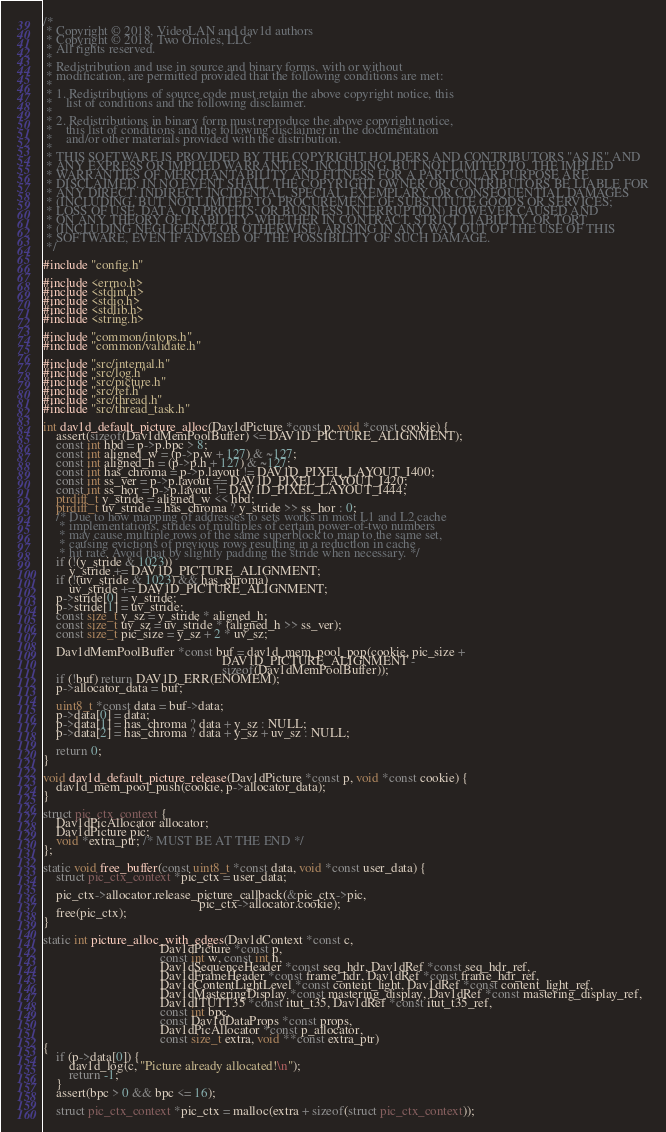Convert code to text. <code><loc_0><loc_0><loc_500><loc_500><_C_>/*
 * Copyright © 2018, VideoLAN and dav1d authors
 * Copyright © 2018, Two Orioles, LLC
 * All rights reserved.
 *
 * Redistribution and use in source and binary forms, with or without
 * modification, are permitted provided that the following conditions are met:
 *
 * 1. Redistributions of source code must retain the above copyright notice, this
 *    list of conditions and the following disclaimer.
 *
 * 2. Redistributions in binary form must reproduce the above copyright notice,
 *    this list of conditions and the following disclaimer in the documentation
 *    and/or other materials provided with the distribution.
 *
 * THIS SOFTWARE IS PROVIDED BY THE COPYRIGHT HOLDERS AND CONTRIBUTORS "AS IS" AND
 * ANY EXPRESS OR IMPLIED WARRANTIES, INCLUDING, BUT NOT LIMITED TO, THE IMPLIED
 * WARRANTIES OF MERCHANTABILITY AND FITNESS FOR A PARTICULAR PURPOSE ARE
 * DISCLAIMED. IN NO EVENT SHALL THE COPYRIGHT OWNER OR CONTRIBUTORS BE LIABLE FOR
 * ANY DIRECT, INDIRECT, INCIDENTAL, SPECIAL, EXEMPLARY, OR CONSEQUENTIAL DAMAGES
 * (INCLUDING, BUT NOT LIMITED TO, PROCUREMENT OF SUBSTITUTE GOODS OR SERVICES;
 * LOSS OF USE, DATA, OR PROFITS; OR BUSINESS INTERRUPTION) HOWEVER CAUSED AND
 * ON ANY THEORY OF LIABILITY, WHETHER IN CONTRACT, STRICT LIABILITY, OR TORT
 * (INCLUDING NEGLIGENCE OR OTHERWISE) ARISING IN ANY WAY OUT OF THE USE OF THIS
 * SOFTWARE, EVEN IF ADVISED OF THE POSSIBILITY OF SUCH DAMAGE.
 */

#include "config.h"

#include <errno.h>
#include <stdint.h>
#include <stdio.h>
#include <stdlib.h>
#include <string.h>

#include "common/intops.h"
#include "common/validate.h"

#include "src/internal.h"
#include "src/log.h"
#include "src/picture.h"
#include "src/ref.h"
#include "src/thread.h"
#include "src/thread_task.h"

int dav1d_default_picture_alloc(Dav1dPicture *const p, void *const cookie) {
    assert(sizeof(Dav1dMemPoolBuffer) <= DAV1D_PICTURE_ALIGNMENT);
    const int hbd = p->p.bpc > 8;
    const int aligned_w = (p->p.w + 127) & ~127;
    const int aligned_h = (p->p.h + 127) & ~127;
    const int has_chroma = p->p.layout != DAV1D_PIXEL_LAYOUT_I400;
    const int ss_ver = p->p.layout == DAV1D_PIXEL_LAYOUT_I420;
    const int ss_hor = p->p.layout != DAV1D_PIXEL_LAYOUT_I444;
    ptrdiff_t y_stride = aligned_w << hbd;
    ptrdiff_t uv_stride = has_chroma ? y_stride >> ss_hor : 0;
    /* Due to how mapping of addresses to sets works in most L1 and L2 cache
     * implementations, strides of multiples of certain power-of-two numbers
     * may cause multiple rows of the same superblock to map to the same set,
     * causing evictions of previous rows resulting in a reduction in cache
     * hit rate. Avoid that by slightly padding the stride when necessary. */
    if (!(y_stride & 1023))
        y_stride += DAV1D_PICTURE_ALIGNMENT;
    if (!(uv_stride & 1023) && has_chroma)
        uv_stride += DAV1D_PICTURE_ALIGNMENT;
    p->stride[0] = y_stride;
    p->stride[1] = uv_stride;
    const size_t y_sz = y_stride * aligned_h;
    const size_t uv_sz = uv_stride * (aligned_h >> ss_ver);
    const size_t pic_size = y_sz + 2 * uv_sz;

    Dav1dMemPoolBuffer *const buf = dav1d_mem_pool_pop(cookie, pic_size +
                                                       DAV1D_PICTURE_ALIGNMENT -
                                                       sizeof(Dav1dMemPoolBuffer));
    if (!buf) return DAV1D_ERR(ENOMEM);
    p->allocator_data = buf;

    uint8_t *const data = buf->data;
    p->data[0] = data;
    p->data[1] = has_chroma ? data + y_sz : NULL;
    p->data[2] = has_chroma ? data + y_sz + uv_sz : NULL;

    return 0;
}

void dav1d_default_picture_release(Dav1dPicture *const p, void *const cookie) {
    dav1d_mem_pool_push(cookie, p->allocator_data);
}

struct pic_ctx_context {
    Dav1dPicAllocator allocator;
    Dav1dPicture pic;
    void *extra_ptr; /* MUST BE AT THE END */
};

static void free_buffer(const uint8_t *const data, void *const user_data) {
    struct pic_ctx_context *pic_ctx = user_data;

    pic_ctx->allocator.release_picture_callback(&pic_ctx->pic,
                                                pic_ctx->allocator.cookie);
    free(pic_ctx);
}

static int picture_alloc_with_edges(Dav1dContext *const c,
                                    Dav1dPicture *const p,
                                    const int w, const int h,
                                    Dav1dSequenceHeader *const seq_hdr, Dav1dRef *const seq_hdr_ref,
                                    Dav1dFrameHeader *const frame_hdr, Dav1dRef *const frame_hdr_ref,
                                    Dav1dContentLightLevel *const content_light, Dav1dRef *const content_light_ref,
                                    Dav1dMasteringDisplay *const mastering_display, Dav1dRef *const mastering_display_ref,
                                    Dav1dITUTT35 *const itut_t35, Dav1dRef *const itut_t35_ref,
                                    const int bpc,
                                    const Dav1dDataProps *const props,
                                    Dav1dPicAllocator *const p_allocator,
                                    const size_t extra, void **const extra_ptr)
{
    if (p->data[0]) {
        dav1d_log(c, "Picture already allocated!\n");
        return -1;
    }
    assert(bpc > 0 && bpc <= 16);

    struct pic_ctx_context *pic_ctx = malloc(extra + sizeof(struct pic_ctx_context));</code> 